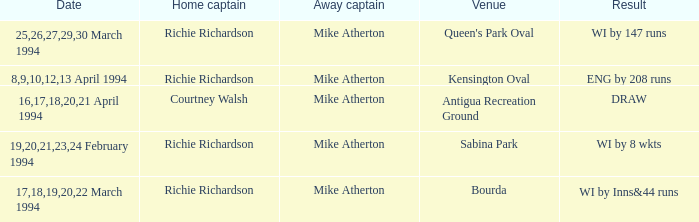Which Home Captain has Eng by 208 runs? Richie Richardson. 